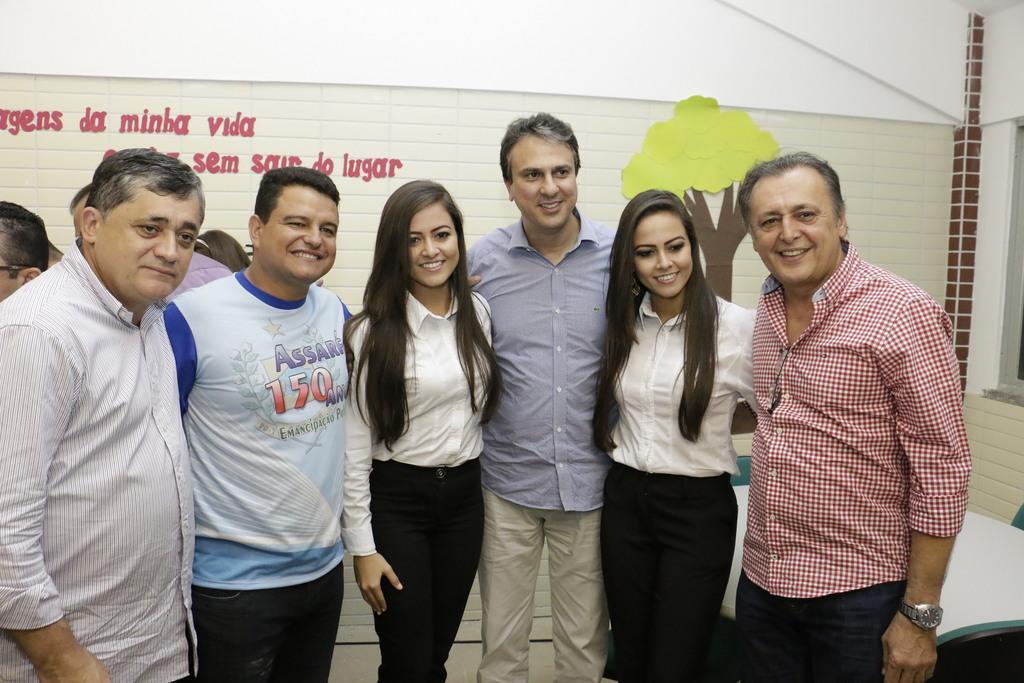Could you give a brief overview of what you see in this image? In this picture we can see some people are standing and taking the picture, behind we can see some people and one table, we can see the banner to the wall. 